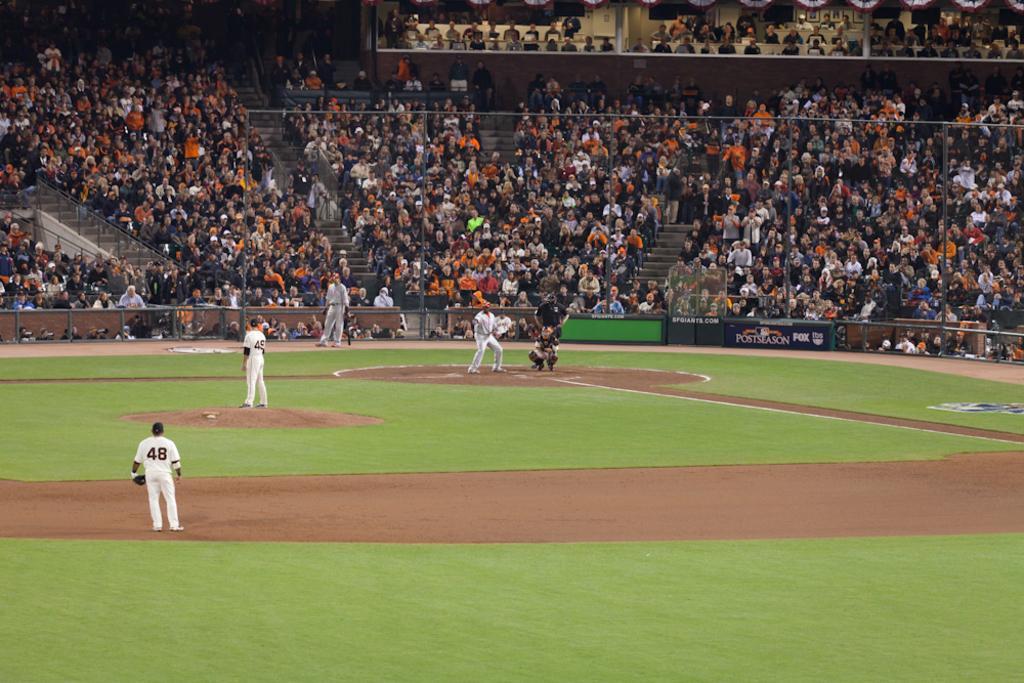Could you give a brief overview of what you see in this image? In this picture we can observe a baseball ground. There are some baseball players in this ground. We can observe some people sitting in the chairs behind the fence. There are men and women in this picture. 